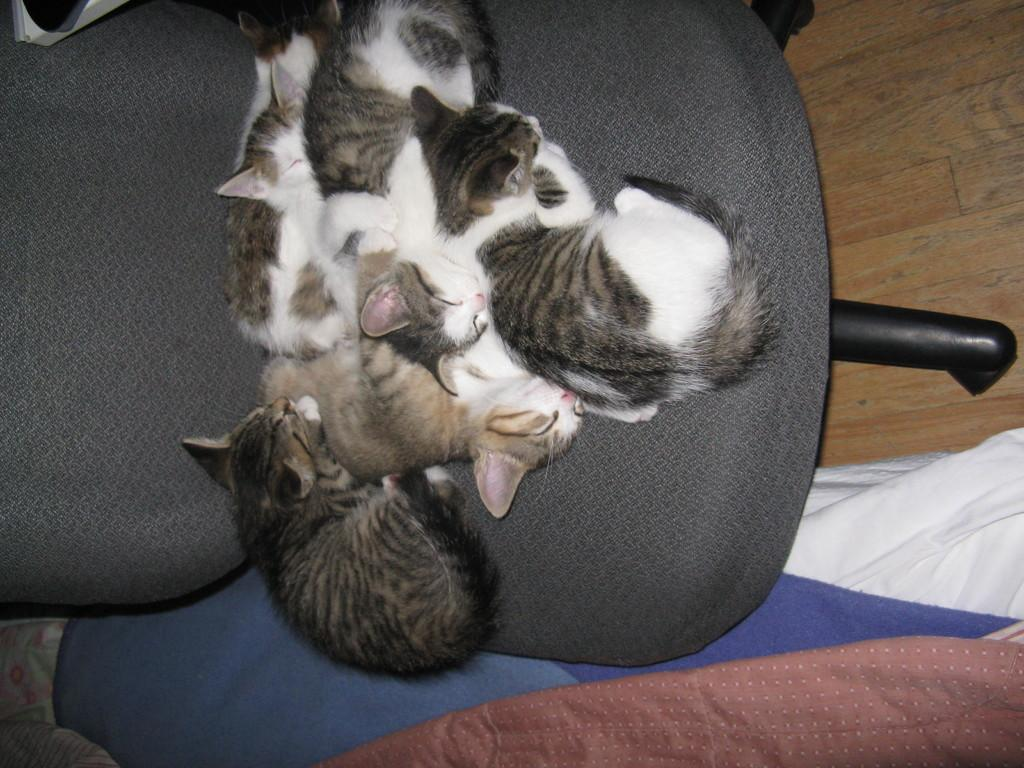What animals are in the foreground of the image? There are cats in the foreground of the image. Where are the cats located? The cats are on a chair. What type of surface is the chair on? The chair is on a wooden surface. What else can be seen at the bottom of the image? There appear to be clothes at the bottom of the image. What type of rice is being shaken in the image? There is no rice or shaking activity present in the image. 